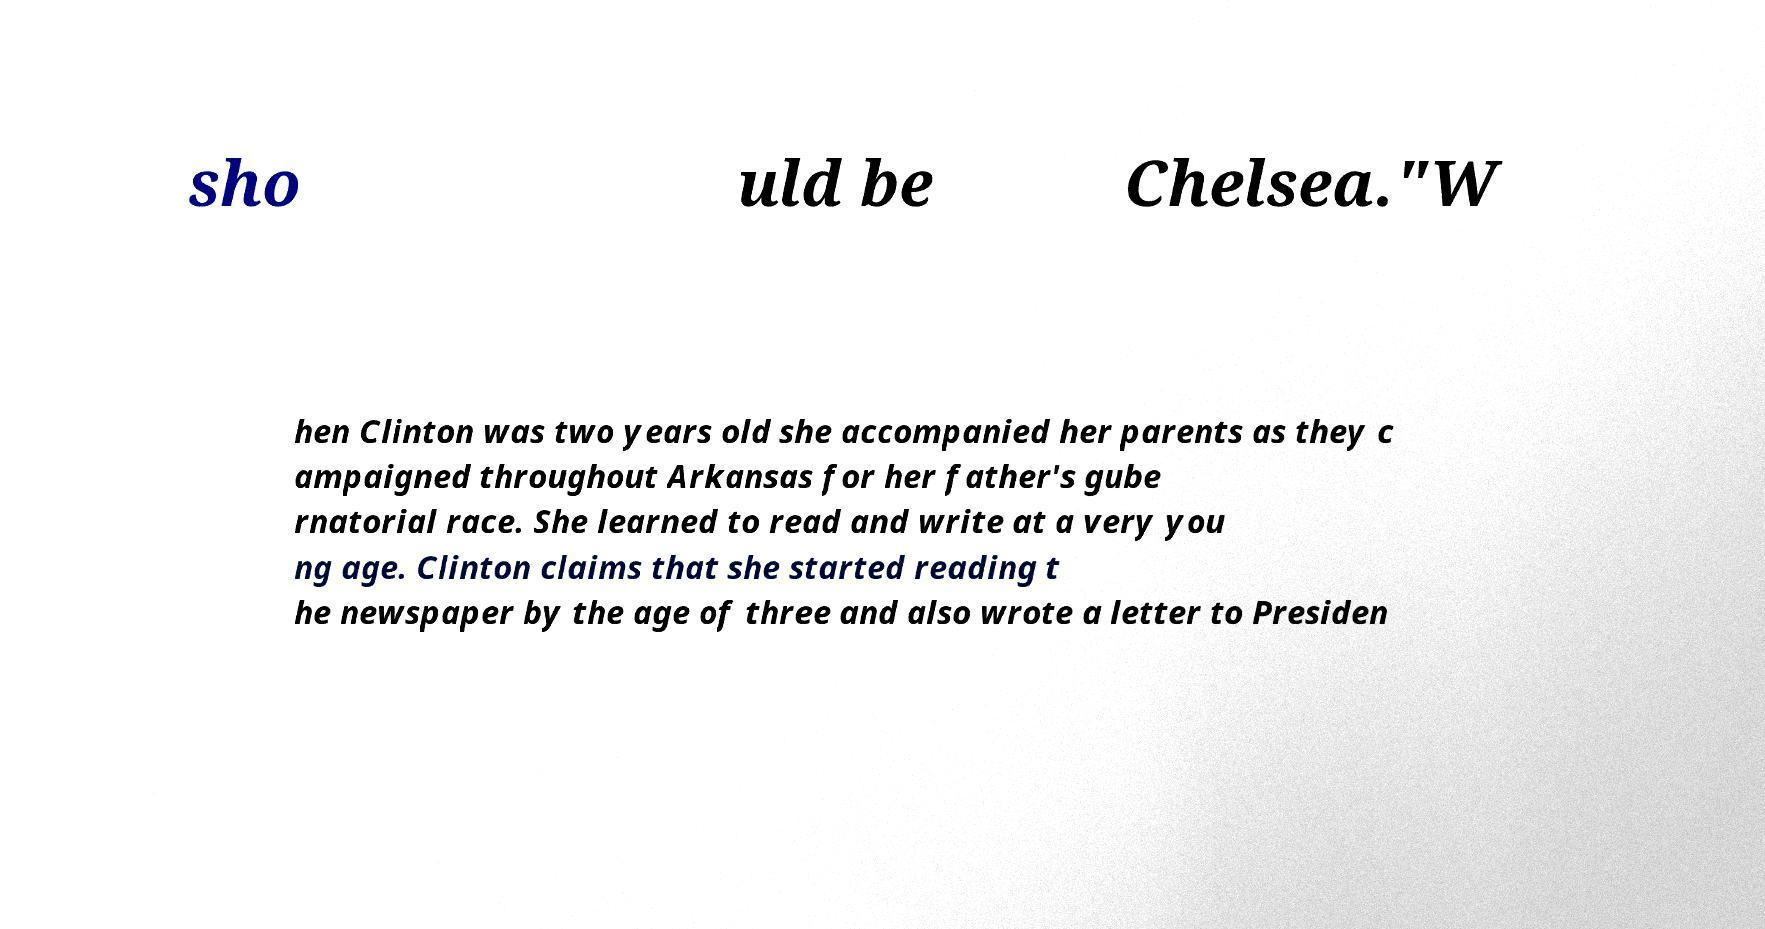For documentation purposes, I need the text within this image transcribed. Could you provide that? sho uld be Chelsea."W hen Clinton was two years old she accompanied her parents as they c ampaigned throughout Arkansas for her father's gube rnatorial race. She learned to read and write at a very you ng age. Clinton claims that she started reading t he newspaper by the age of three and also wrote a letter to Presiden 